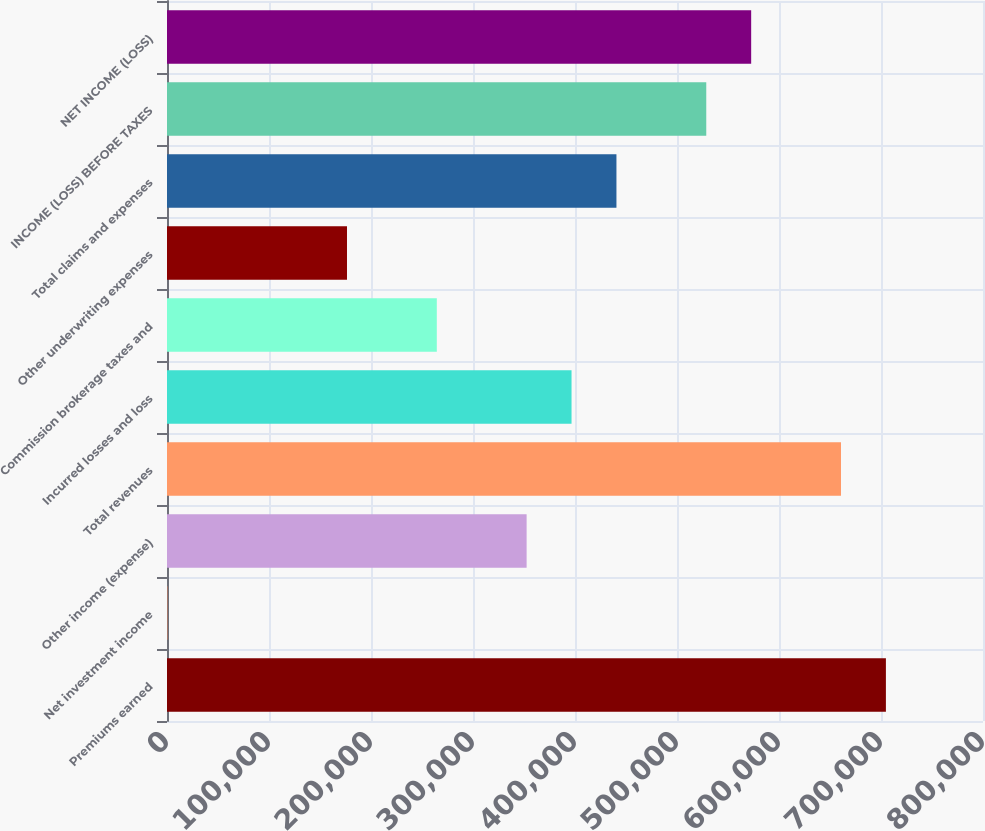Convert chart. <chart><loc_0><loc_0><loc_500><loc_500><bar_chart><fcel>Premiums earned<fcel>Net investment income<fcel>Other income (expense)<fcel>Total revenues<fcel>Incurred losses and loss<fcel>Commission brokerage taxes and<fcel>Other underwriting expenses<fcel>Total claims and expenses<fcel>INCOME (LOSS) BEFORE TAXES<fcel>NET INCOME (LOSS)<nl><fcel>704806<fcel>352<fcel>352579<fcel>660778<fcel>396608<fcel>264522<fcel>176466<fcel>440636<fcel>528693<fcel>572721<nl></chart> 